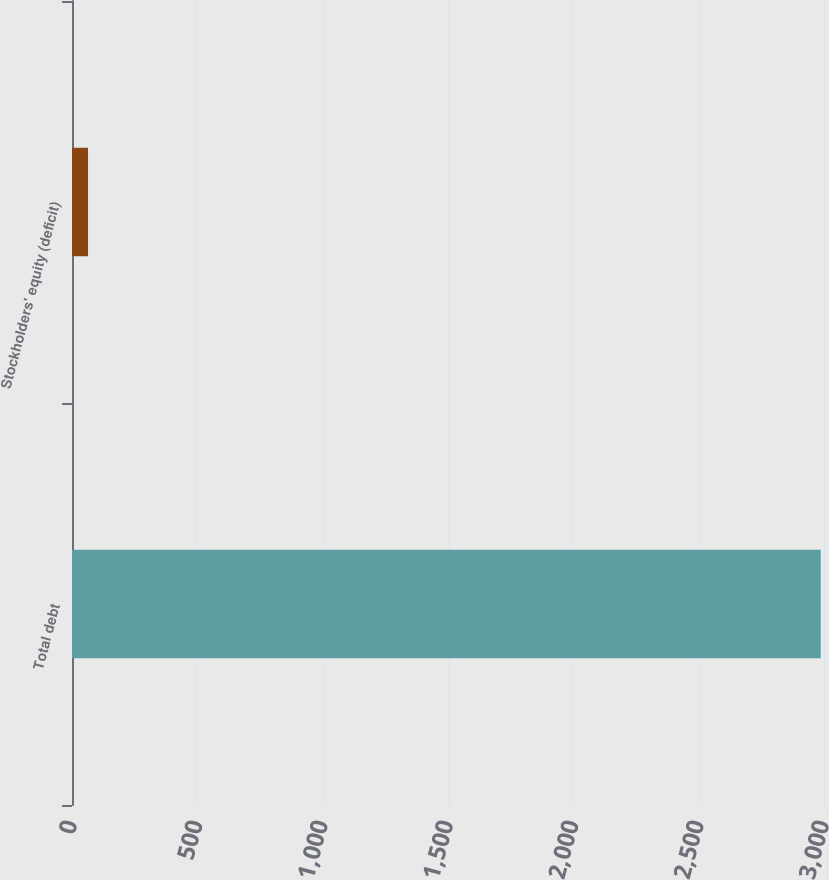<chart> <loc_0><loc_0><loc_500><loc_500><bar_chart><fcel>Total debt<fcel>Stockholders' equity (deficit)<nl><fcel>2987<fcel>64<nl></chart> 